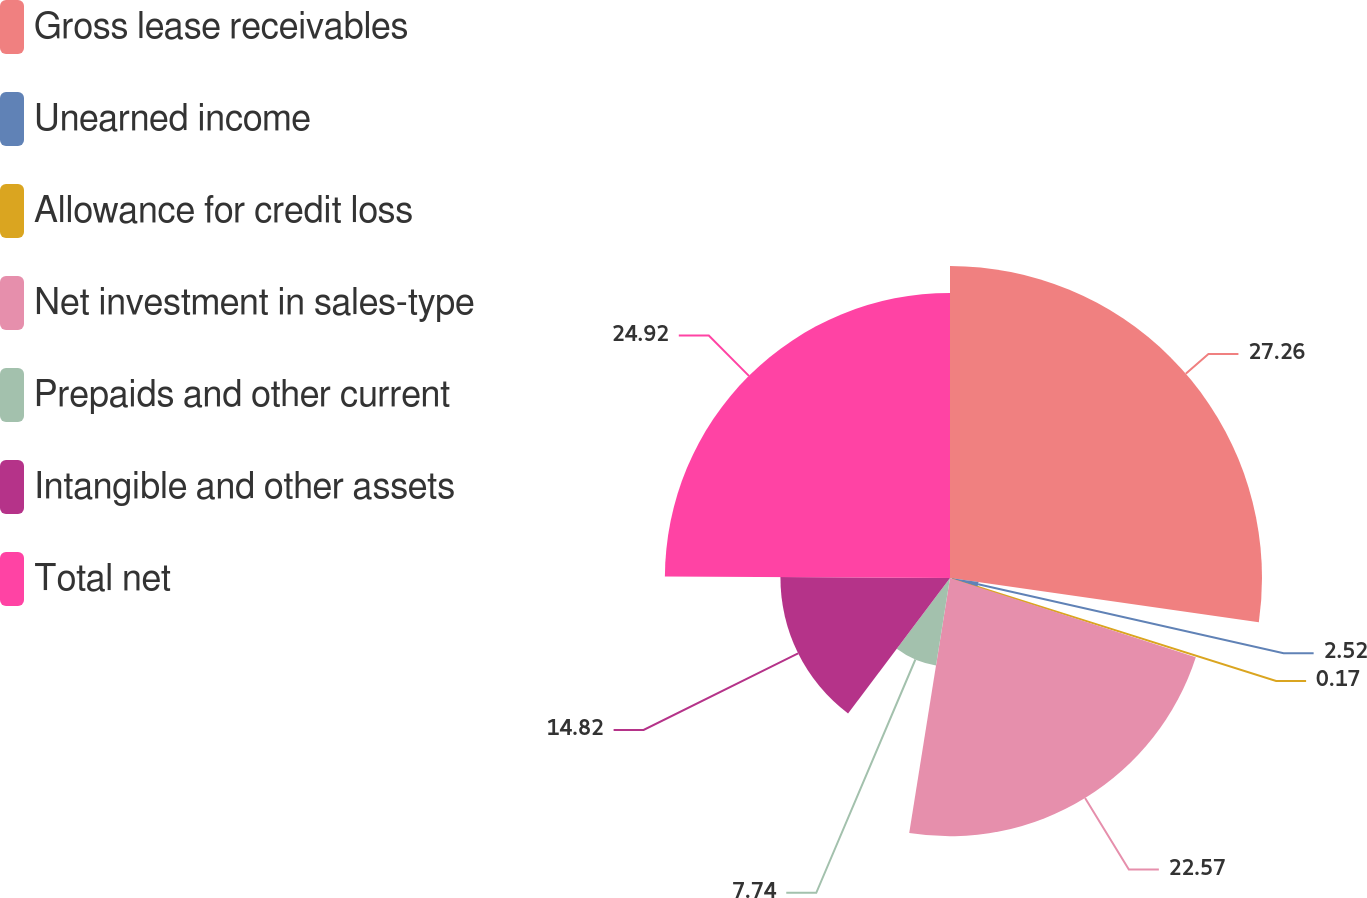Convert chart. <chart><loc_0><loc_0><loc_500><loc_500><pie_chart><fcel>Gross lease receivables<fcel>Unearned income<fcel>Allowance for credit loss<fcel>Net investment in sales-type<fcel>Prepaids and other current<fcel>Intangible and other assets<fcel>Total net<nl><fcel>27.27%<fcel>2.52%<fcel>0.17%<fcel>22.57%<fcel>7.74%<fcel>14.82%<fcel>24.92%<nl></chart> 